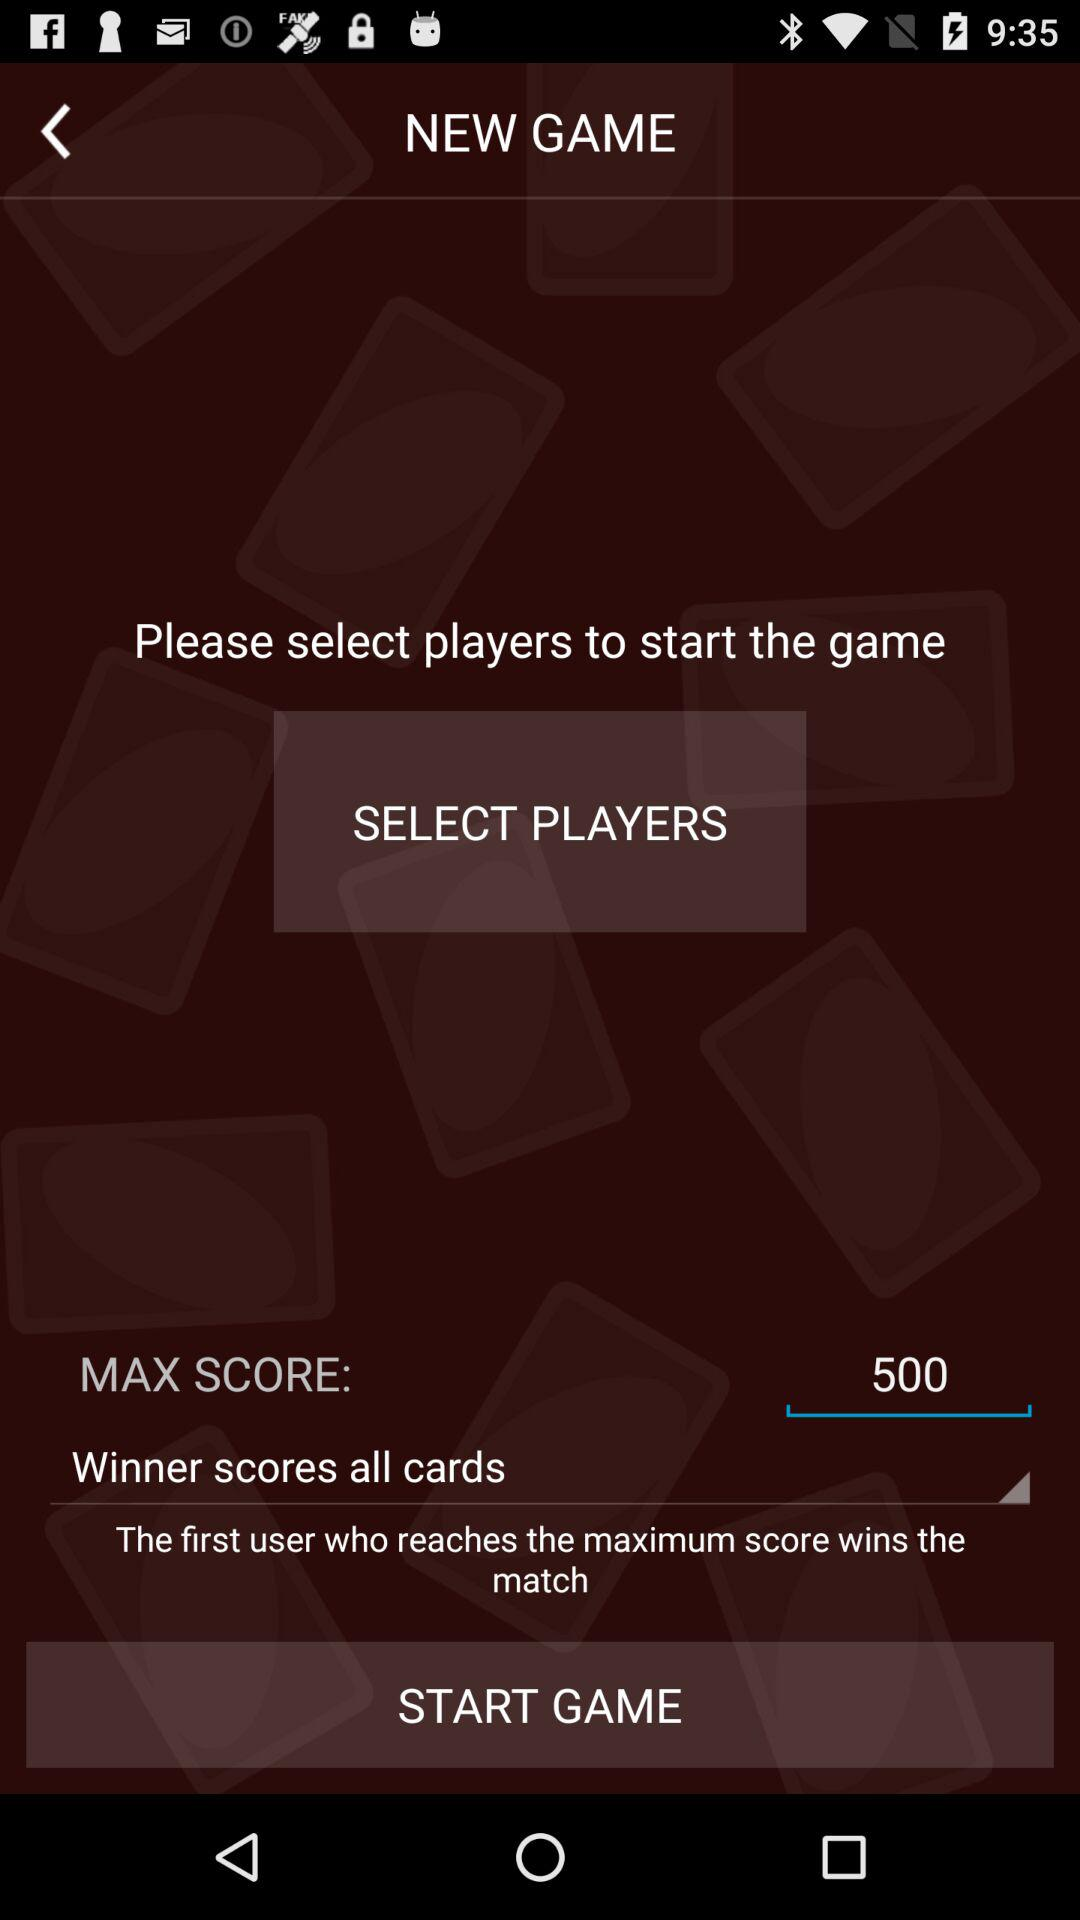Who wins the match? The first user who reaches the maximum score wins the match. 